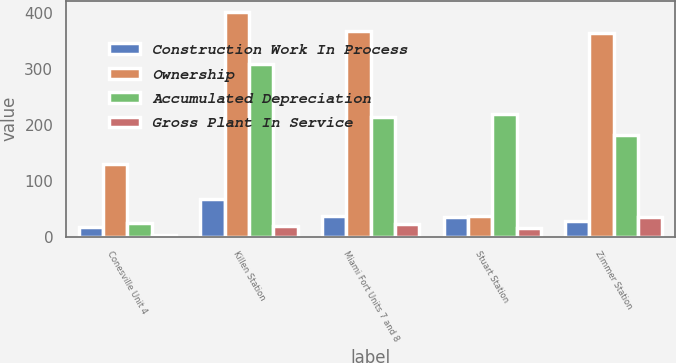<chart> <loc_0><loc_0><loc_500><loc_500><stacked_bar_chart><ecel><fcel>Conesville Unit 4<fcel>Killen Station<fcel>Miami Fort Units 7 and 8<fcel>Stuart Station<fcel>Zimmer Station<nl><fcel>Construction Work In Process<fcel>17<fcel>67<fcel>36<fcel>35<fcel>28<nl><fcel>Ownership<fcel>129<fcel>402<fcel>368<fcel>36<fcel>365<nl><fcel>Accumulated Depreciation<fcel>24<fcel>308<fcel>214<fcel>219<fcel>182<nl><fcel>Gross Plant In Service<fcel>2<fcel>19<fcel>23<fcel>16<fcel>35<nl></chart> 